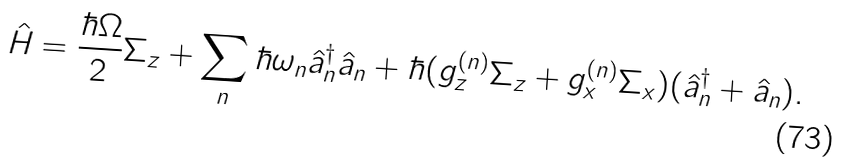<formula> <loc_0><loc_0><loc_500><loc_500>\hat { H } = \frac { \hbar { \Omega } } { 2 } \Sigma _ { z } + \sum _ { n } \hbar { \omega } _ { n } \hat { a } _ { n } ^ { \dagger } \hat { a } _ { n } + \hbar { ( } g _ { z } ^ { ( n ) } \Sigma _ { z } + g _ { x } ^ { ( n ) } \Sigma _ { x } ) ( \hat { a } _ { n } ^ { \dagger } + \hat { a } _ { n } ) .</formula> 